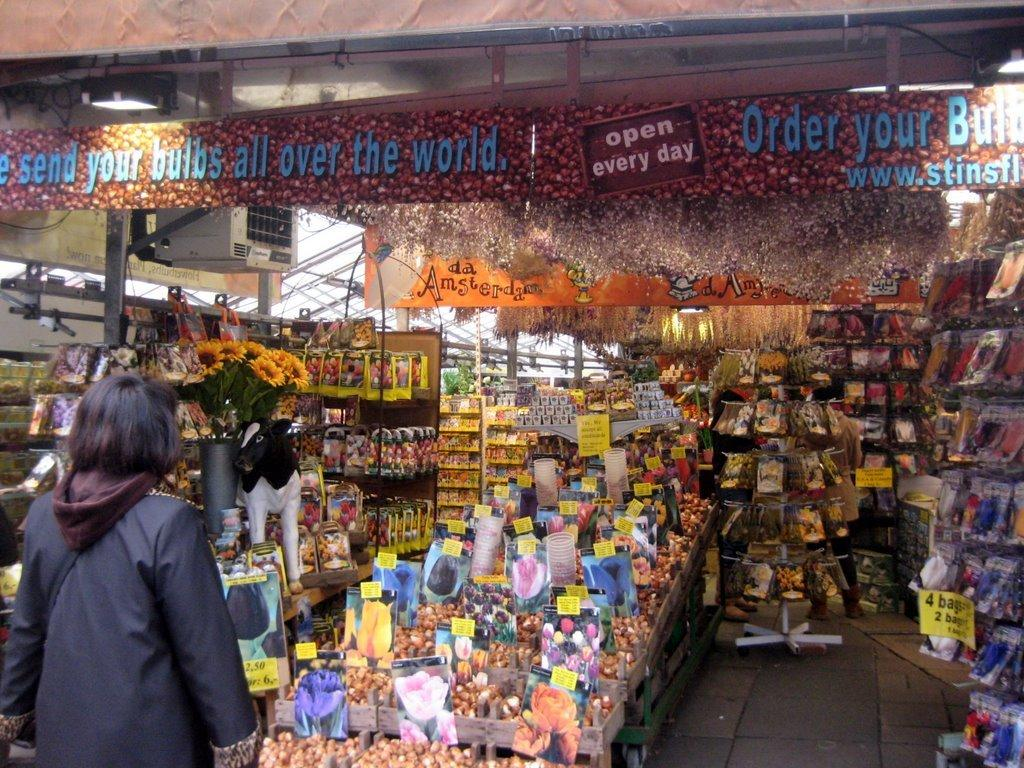<image>
Present a compact description of the photo's key features. a flower bulb shop is open every day of the week 